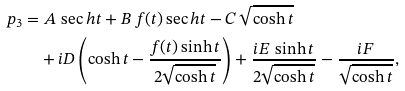<formula> <loc_0><loc_0><loc_500><loc_500>p _ { 3 } & = A \, \sec h t + B \, f ( t ) \sec h t - C \, \sqrt { \cosh t } \\ & \quad + i D \left ( \cosh t - \frac { f ( t ) \sinh t } { 2 \sqrt { \cosh t } } \right ) + \frac { i E \, \sinh t } { 2 \sqrt { \cosh t } } - \frac { i F } { \sqrt { \cosh t } } ,</formula> 